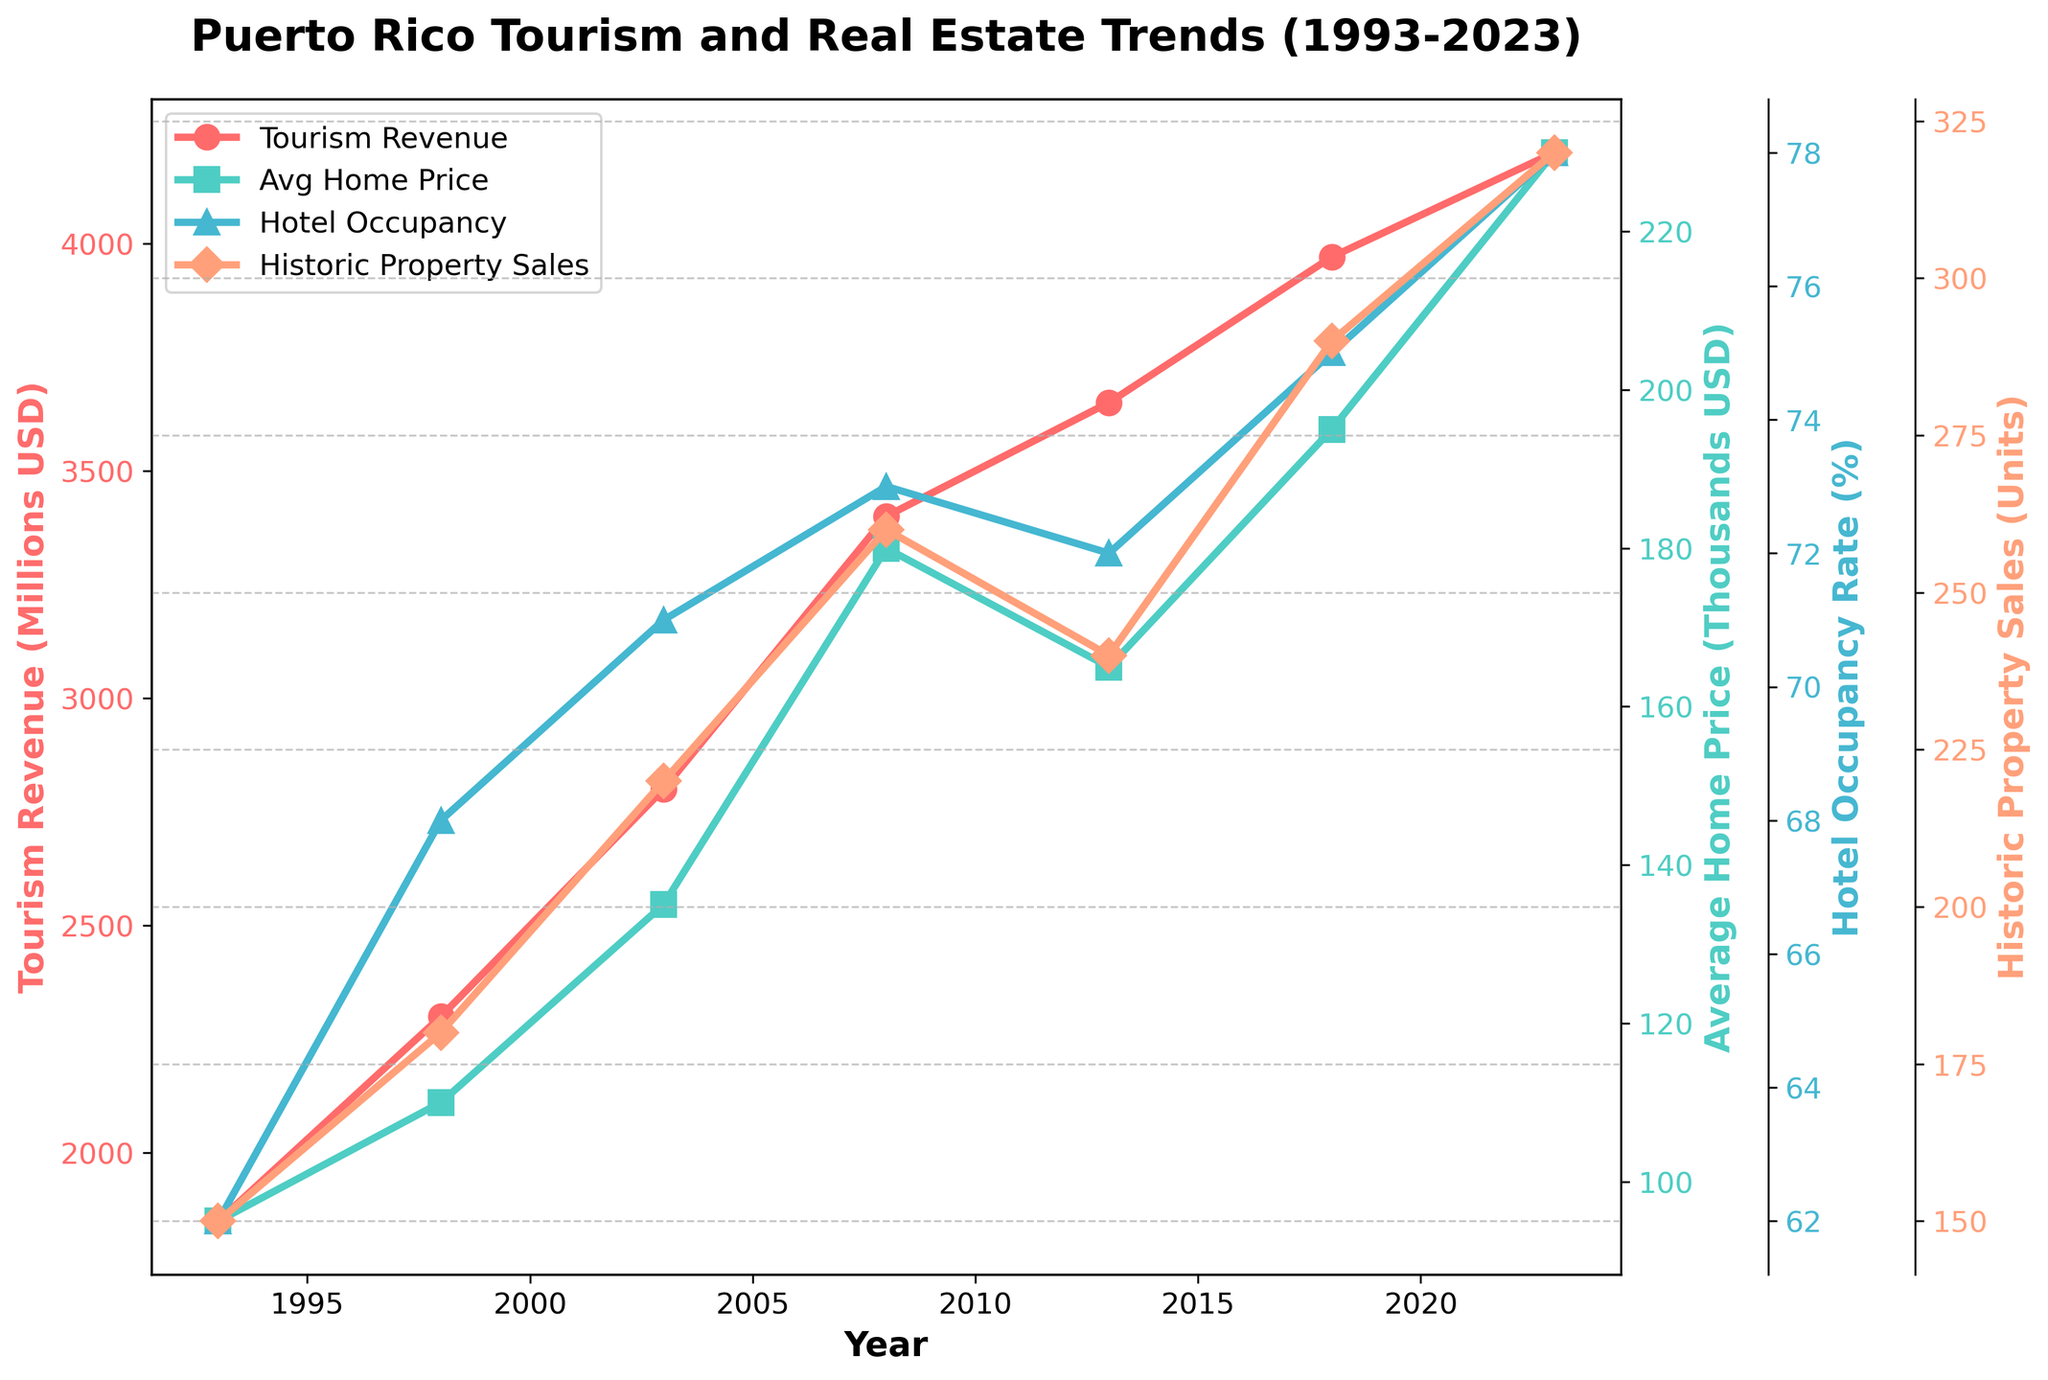What is the overall trend of tourism revenue from 1993 to 2023? Based on the line showing tourism revenue in the figure, we can observe that it consistently increases over the 30-year period, indicating an upward trend.
Answer: Increasing Between which years did the average home price increase the most? By comparing the differences in average home prices year-over-year, the jump from 2003 ($135k) to 2008 ($180k) is the largest, showing a $45k increase.
Answer: 2003 to 2008 What was the hotel occupancy rate in 2013, and how did it compare to 2023? From the plot, the hotel occupancy rate in 2013 is visible at around 72%, and in 2023, it's approximately 78%. Comparing these, there's an increase of 6%.
Answer: In 2013, it was 72%. In 2023, it was 78% How do historical property sales in 1993 compare to 2023? By examining the historical property sales values in the figure, in 1993 sales were 150 units and in 2023 they were 320 units, nearly more than double the number of units sold in 1993.
Answer: In 1993, it was 150 units. In 2023, it was 320 units Is there a corresponding change in average home prices and tourism revenue? Reviewing the line charts, as tourism revenue (red line) increases consistently, the average home price (green line) also follows with general increases, suggesting a positive correlation.
Answer: Yes, they both increase Which variable showed the smallest change over the 30 years? Comparing the trends of each variable, the hotel occupancy rate exhibited smaller yearly fluctuations compared to the significant changes seen in tourism revenue, average home price, and historical property sales.
Answer: Hotel occupancy rate What is the rate of increase in tourism revenue from 1993 to 2023? Calculate the rate of increase by dividing the difference between 2023 and 1993 revenues by the revenue in 1993: (4200 - 1850) / 1850 ≈ 1.27 or 127%.
Answer: 127% By how much did the average home price change from 1998 to 2023? The home price in 1998 was $110k, and in 2023 it was $230k. The change is 230 - 110 = $120k.
Answer: $120k Identify the year with the highest historic property sales. From the plot, the peak in historic property sales is in 2023 with 320 units.
Answer: 2023 What is the relationship between hotel occupancy rates and historic property sales? Observing their lines on the plot, both hotel occupancy rates (blue line) and historic property sales (orange line) increase over the period, suggesting a positively correlated relationship.
Answer: Positively correlated 